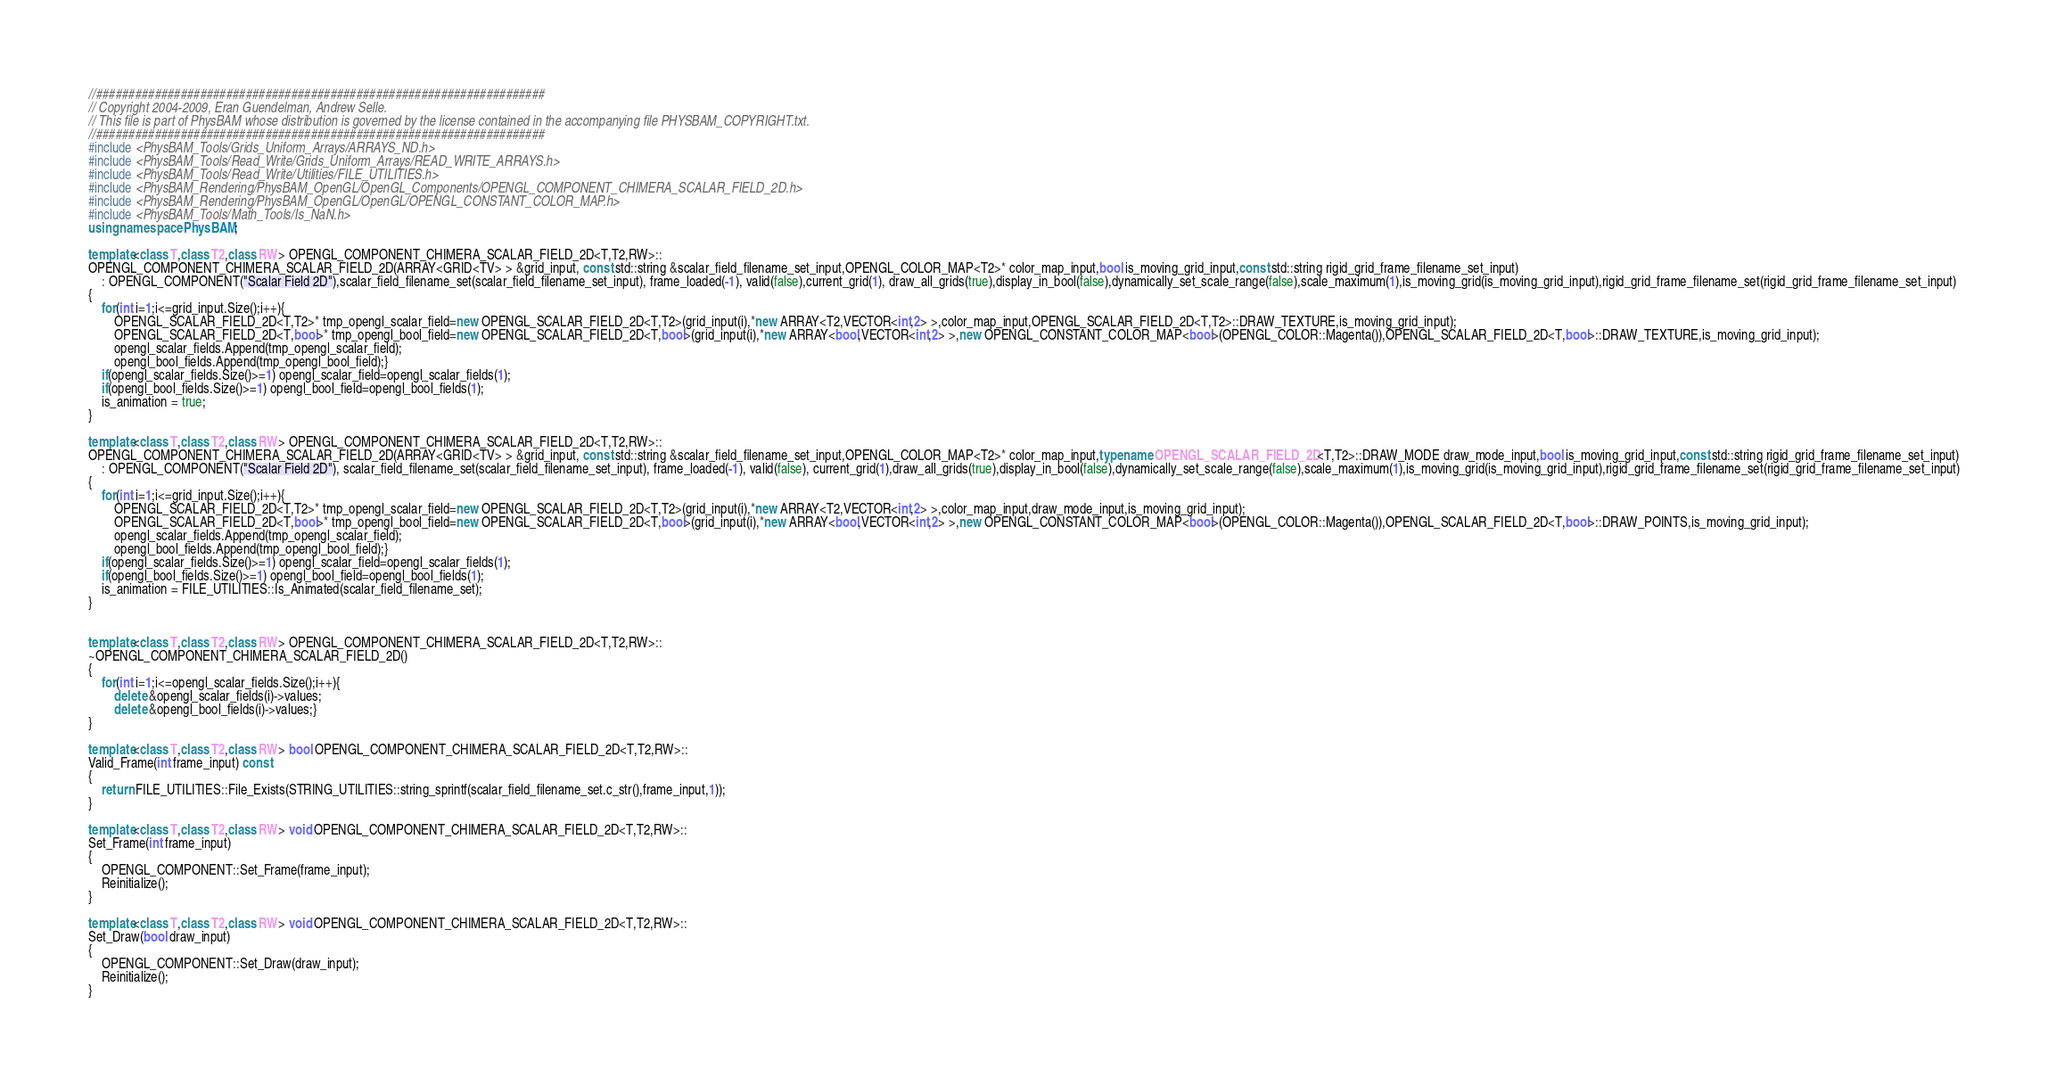Convert code to text. <code><loc_0><loc_0><loc_500><loc_500><_C++_>//#####################################################################
// Copyright 2004-2009, Eran Guendelman, Andrew Selle.
// This file is part of PhysBAM whose distribution is governed by the license contained in the accompanying file PHYSBAM_COPYRIGHT.txt.
//#####################################################################
#include <PhysBAM_Tools/Grids_Uniform_Arrays/ARRAYS_ND.h>
#include <PhysBAM_Tools/Read_Write/Grids_Uniform_Arrays/READ_WRITE_ARRAYS.h>
#include <PhysBAM_Tools/Read_Write/Utilities/FILE_UTILITIES.h>
#include <PhysBAM_Rendering/PhysBAM_OpenGL/OpenGL_Components/OPENGL_COMPONENT_CHIMERA_SCALAR_FIELD_2D.h>
#include <PhysBAM_Rendering/PhysBAM_OpenGL/OpenGL/OPENGL_CONSTANT_COLOR_MAP.h>
#include <PhysBAM_Tools/Math_Tools/Is_NaN.h>
using namespace PhysBAM;

template<class T,class T2,class RW> OPENGL_COMPONENT_CHIMERA_SCALAR_FIELD_2D<T,T2,RW>::
OPENGL_COMPONENT_CHIMERA_SCALAR_FIELD_2D(ARRAY<GRID<TV> > &grid_input, const std::string &scalar_field_filename_set_input,OPENGL_COLOR_MAP<T2>* color_map_input,bool is_moving_grid_input,const std::string rigid_grid_frame_filename_set_input)
    : OPENGL_COMPONENT("Scalar Field 2D"),scalar_field_filename_set(scalar_field_filename_set_input), frame_loaded(-1), valid(false),current_grid(1), draw_all_grids(true),display_in_bool(false),dynamically_set_scale_range(false),scale_maximum(1),is_moving_grid(is_moving_grid_input),rigid_grid_frame_filename_set(rigid_grid_frame_filename_set_input)
{
    for(int i=1;i<=grid_input.Size();i++){
        OPENGL_SCALAR_FIELD_2D<T,T2>* tmp_opengl_scalar_field=new OPENGL_SCALAR_FIELD_2D<T,T2>(grid_input(i),*new ARRAY<T2,VECTOR<int,2> >,color_map_input,OPENGL_SCALAR_FIELD_2D<T,T2>::DRAW_TEXTURE,is_moving_grid_input);
        OPENGL_SCALAR_FIELD_2D<T,bool>* tmp_opengl_bool_field=new OPENGL_SCALAR_FIELD_2D<T,bool>(grid_input(i),*new ARRAY<bool,VECTOR<int,2> >,new OPENGL_CONSTANT_COLOR_MAP<bool>(OPENGL_COLOR::Magenta()),OPENGL_SCALAR_FIELD_2D<T,bool>::DRAW_TEXTURE,is_moving_grid_input);
        opengl_scalar_fields.Append(tmp_opengl_scalar_field);
        opengl_bool_fields.Append(tmp_opengl_bool_field);}
    if(opengl_scalar_fields.Size()>=1) opengl_scalar_field=opengl_scalar_fields(1);
    if(opengl_bool_fields.Size()>=1) opengl_bool_field=opengl_bool_fields(1);
    is_animation = true; 
}

template<class T,class T2,class RW> OPENGL_COMPONENT_CHIMERA_SCALAR_FIELD_2D<T,T2,RW>::
OPENGL_COMPONENT_CHIMERA_SCALAR_FIELD_2D(ARRAY<GRID<TV> > &grid_input, const std::string &scalar_field_filename_set_input,OPENGL_COLOR_MAP<T2>* color_map_input,typename OPENGL_SCALAR_FIELD_2D<T,T2>::DRAW_MODE draw_mode_input,bool is_moving_grid_input,const std::string rigid_grid_frame_filename_set_input)
    : OPENGL_COMPONENT("Scalar Field 2D"), scalar_field_filename_set(scalar_field_filename_set_input), frame_loaded(-1), valid(false), current_grid(1),draw_all_grids(true),display_in_bool(false),dynamically_set_scale_range(false),scale_maximum(1),is_moving_grid(is_moving_grid_input),rigid_grid_frame_filename_set(rigid_grid_frame_filename_set_input)
{
    for(int i=1;i<=grid_input.Size();i++){
        OPENGL_SCALAR_FIELD_2D<T,T2>* tmp_opengl_scalar_field=new OPENGL_SCALAR_FIELD_2D<T,T2>(grid_input(i),*new ARRAY<T2,VECTOR<int,2> >,color_map_input,draw_mode_input,is_moving_grid_input);
        OPENGL_SCALAR_FIELD_2D<T,bool>* tmp_opengl_bool_field=new OPENGL_SCALAR_FIELD_2D<T,bool>(grid_input(i),*new ARRAY<bool,VECTOR<int,2> >,new OPENGL_CONSTANT_COLOR_MAP<bool>(OPENGL_COLOR::Magenta()),OPENGL_SCALAR_FIELD_2D<T,bool>::DRAW_POINTS,is_moving_grid_input);
        opengl_scalar_fields.Append(tmp_opengl_scalar_field);
        opengl_bool_fields.Append(tmp_opengl_bool_field);}
    if(opengl_scalar_fields.Size()>=1) opengl_scalar_field=opengl_scalar_fields(1);
    if(opengl_bool_fields.Size()>=1) opengl_bool_field=opengl_bool_fields(1);
    is_animation = FILE_UTILITIES::Is_Animated(scalar_field_filename_set);
}


template<class T,class T2,class RW> OPENGL_COMPONENT_CHIMERA_SCALAR_FIELD_2D<T,T2,RW>::
~OPENGL_COMPONENT_CHIMERA_SCALAR_FIELD_2D()
{
    for(int i=1;i<=opengl_scalar_fields.Size();i++){
        delete &opengl_scalar_fields(i)->values;
        delete &opengl_bool_fields(i)->values;}
}

template<class T,class T2,class RW> bool OPENGL_COMPONENT_CHIMERA_SCALAR_FIELD_2D<T,T2,RW>::
Valid_Frame(int frame_input) const
{
    return FILE_UTILITIES::File_Exists(STRING_UTILITIES::string_sprintf(scalar_field_filename_set.c_str(),frame_input,1));
}

template<class T,class T2,class RW> void OPENGL_COMPONENT_CHIMERA_SCALAR_FIELD_2D<T,T2,RW>::
Set_Frame(int frame_input)
{
    OPENGL_COMPONENT::Set_Frame(frame_input);
    Reinitialize();
}

template<class T,class T2,class RW> void OPENGL_COMPONENT_CHIMERA_SCALAR_FIELD_2D<T,T2,RW>::
Set_Draw(bool draw_input)
{
    OPENGL_COMPONENT::Set_Draw(draw_input);
    Reinitialize();
}
</code> 